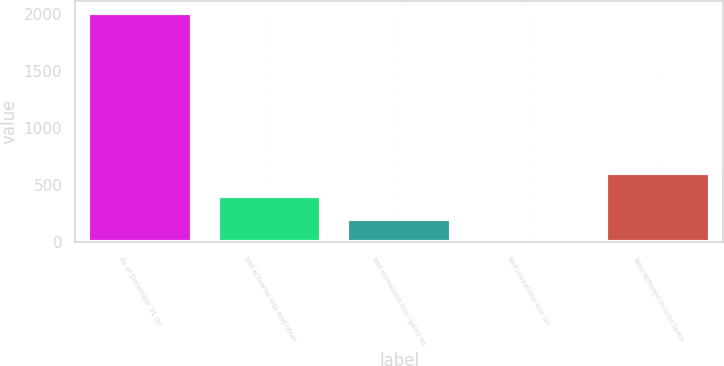<chart> <loc_0><loc_0><loc_500><loc_500><bar_chart><fcel>As of December 31 (in<fcel>Net actuarial loss and other<fcel>Net unrealized loss (gain) on<fcel>Net unrealized loss on<fcel>Total deferred income taxes<nl><fcel>2013<fcel>402.76<fcel>201.48<fcel>0.2<fcel>604.04<nl></chart> 